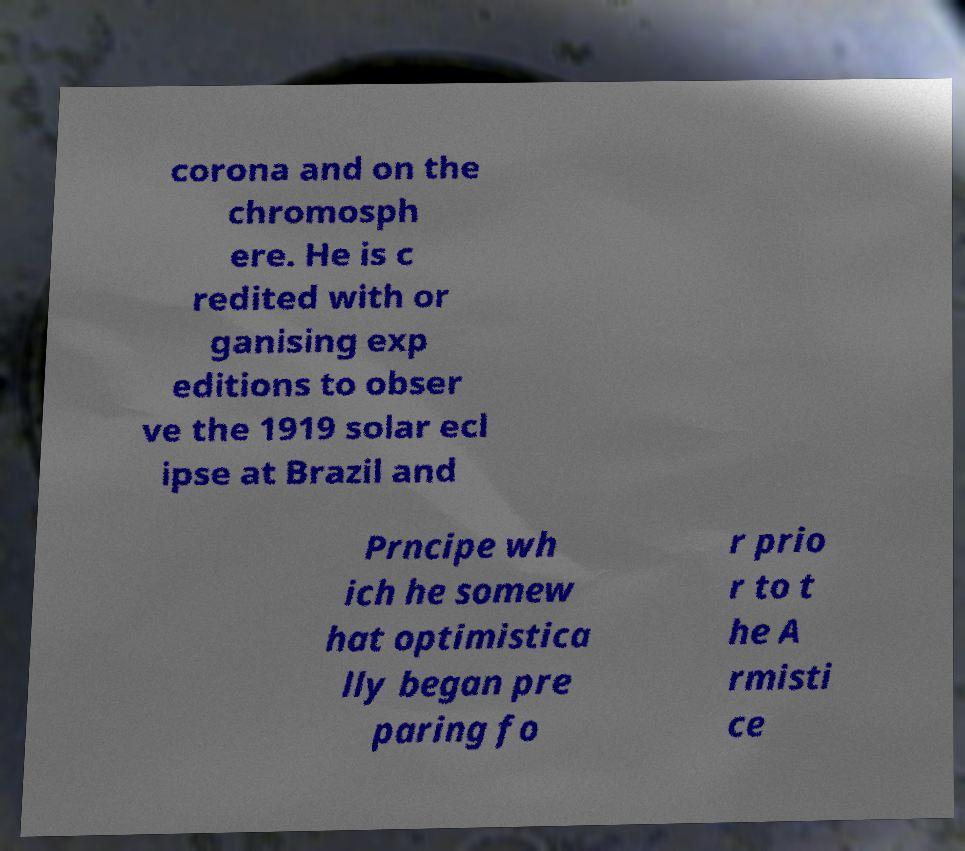Can you read and provide the text displayed in the image?This photo seems to have some interesting text. Can you extract and type it out for me? corona and on the chromosph ere. He is c redited with or ganising exp editions to obser ve the 1919 solar ecl ipse at Brazil and Prncipe wh ich he somew hat optimistica lly began pre paring fo r prio r to t he A rmisti ce 